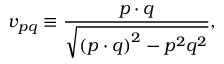<formula> <loc_0><loc_0><loc_500><loc_500>v _ { p q } \equiv \frac { p \cdot q } { \sqrt { \left ( p \cdot q \right ) ^ { 2 } - p ^ { 2 } q ^ { 2 } } } ,</formula> 